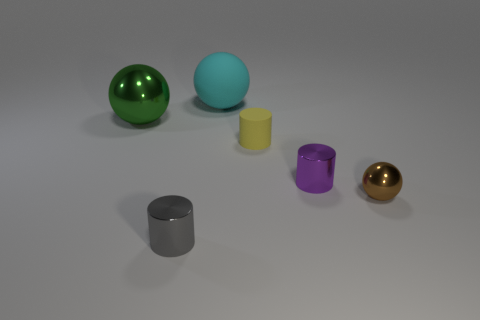Subtract all small shiny cylinders. How many cylinders are left? 1 Add 4 small rubber objects. How many objects exist? 10 Subtract 3 cylinders. How many cylinders are left? 0 Subtract all cyan spheres. How many spheres are left? 2 Add 2 tiny purple shiny things. How many tiny purple shiny things are left? 3 Add 5 big blue shiny cubes. How many big blue shiny cubes exist? 5 Subtract 0 gray cubes. How many objects are left? 6 Subtract all blue cylinders. Subtract all cyan spheres. How many cylinders are left? 3 Subtract all blocks. Subtract all small purple metallic cylinders. How many objects are left? 5 